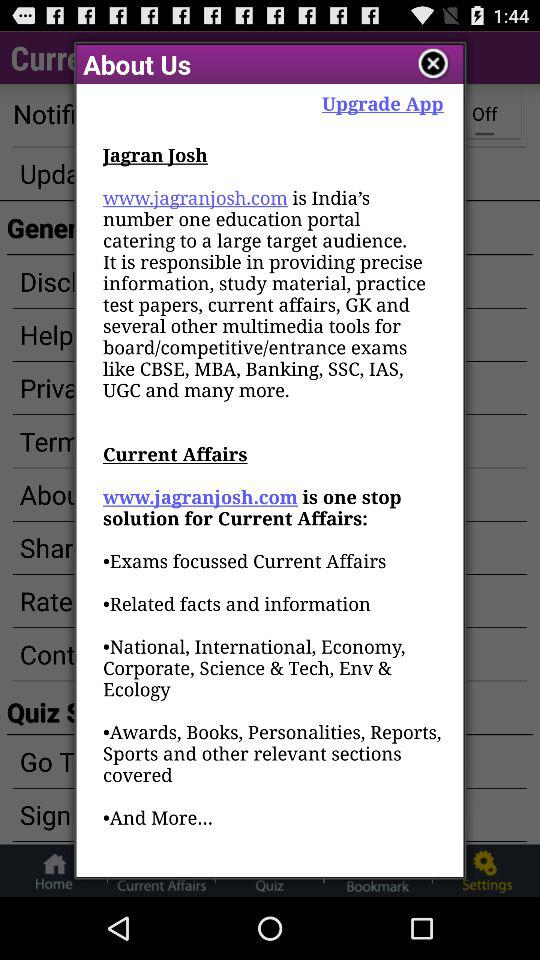What is the web address of "Jagran Josh"? The web address of "Jagran Josh" is www.jagranjosh.com. 